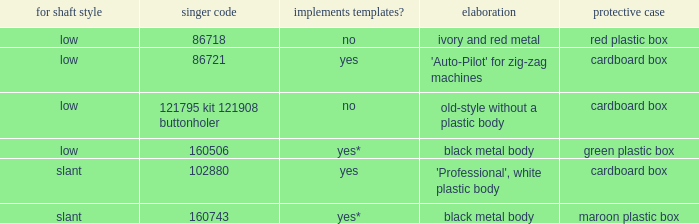Can you give me this table as a dict? {'header': ['for shaft style', 'singer code', 'implements templates?', 'elaboration', 'protective case'], 'rows': [['low', '86718', 'no', 'ivory and red metal', 'red plastic box'], ['low', '86721', 'yes', "'Auto-Pilot' for zig-zag machines", 'cardboard box'], ['low', '121795 kit 121908 buttonholer', 'no', 'old-style without a plastic body', 'cardboard box'], ['low', '160506', 'yes*', 'black metal body', 'green plastic box'], ['slant', '102880', 'yes', "'Professional', white plastic body", 'cardboard box'], ['slant', '160743', 'yes*', 'black metal body', 'maroon plastic box']]} What are all the different descriptions for the buttonholer with cardboard box for storage and a low shank type? 'Auto-Pilot' for zig-zag machines, old-style without a plastic body. 